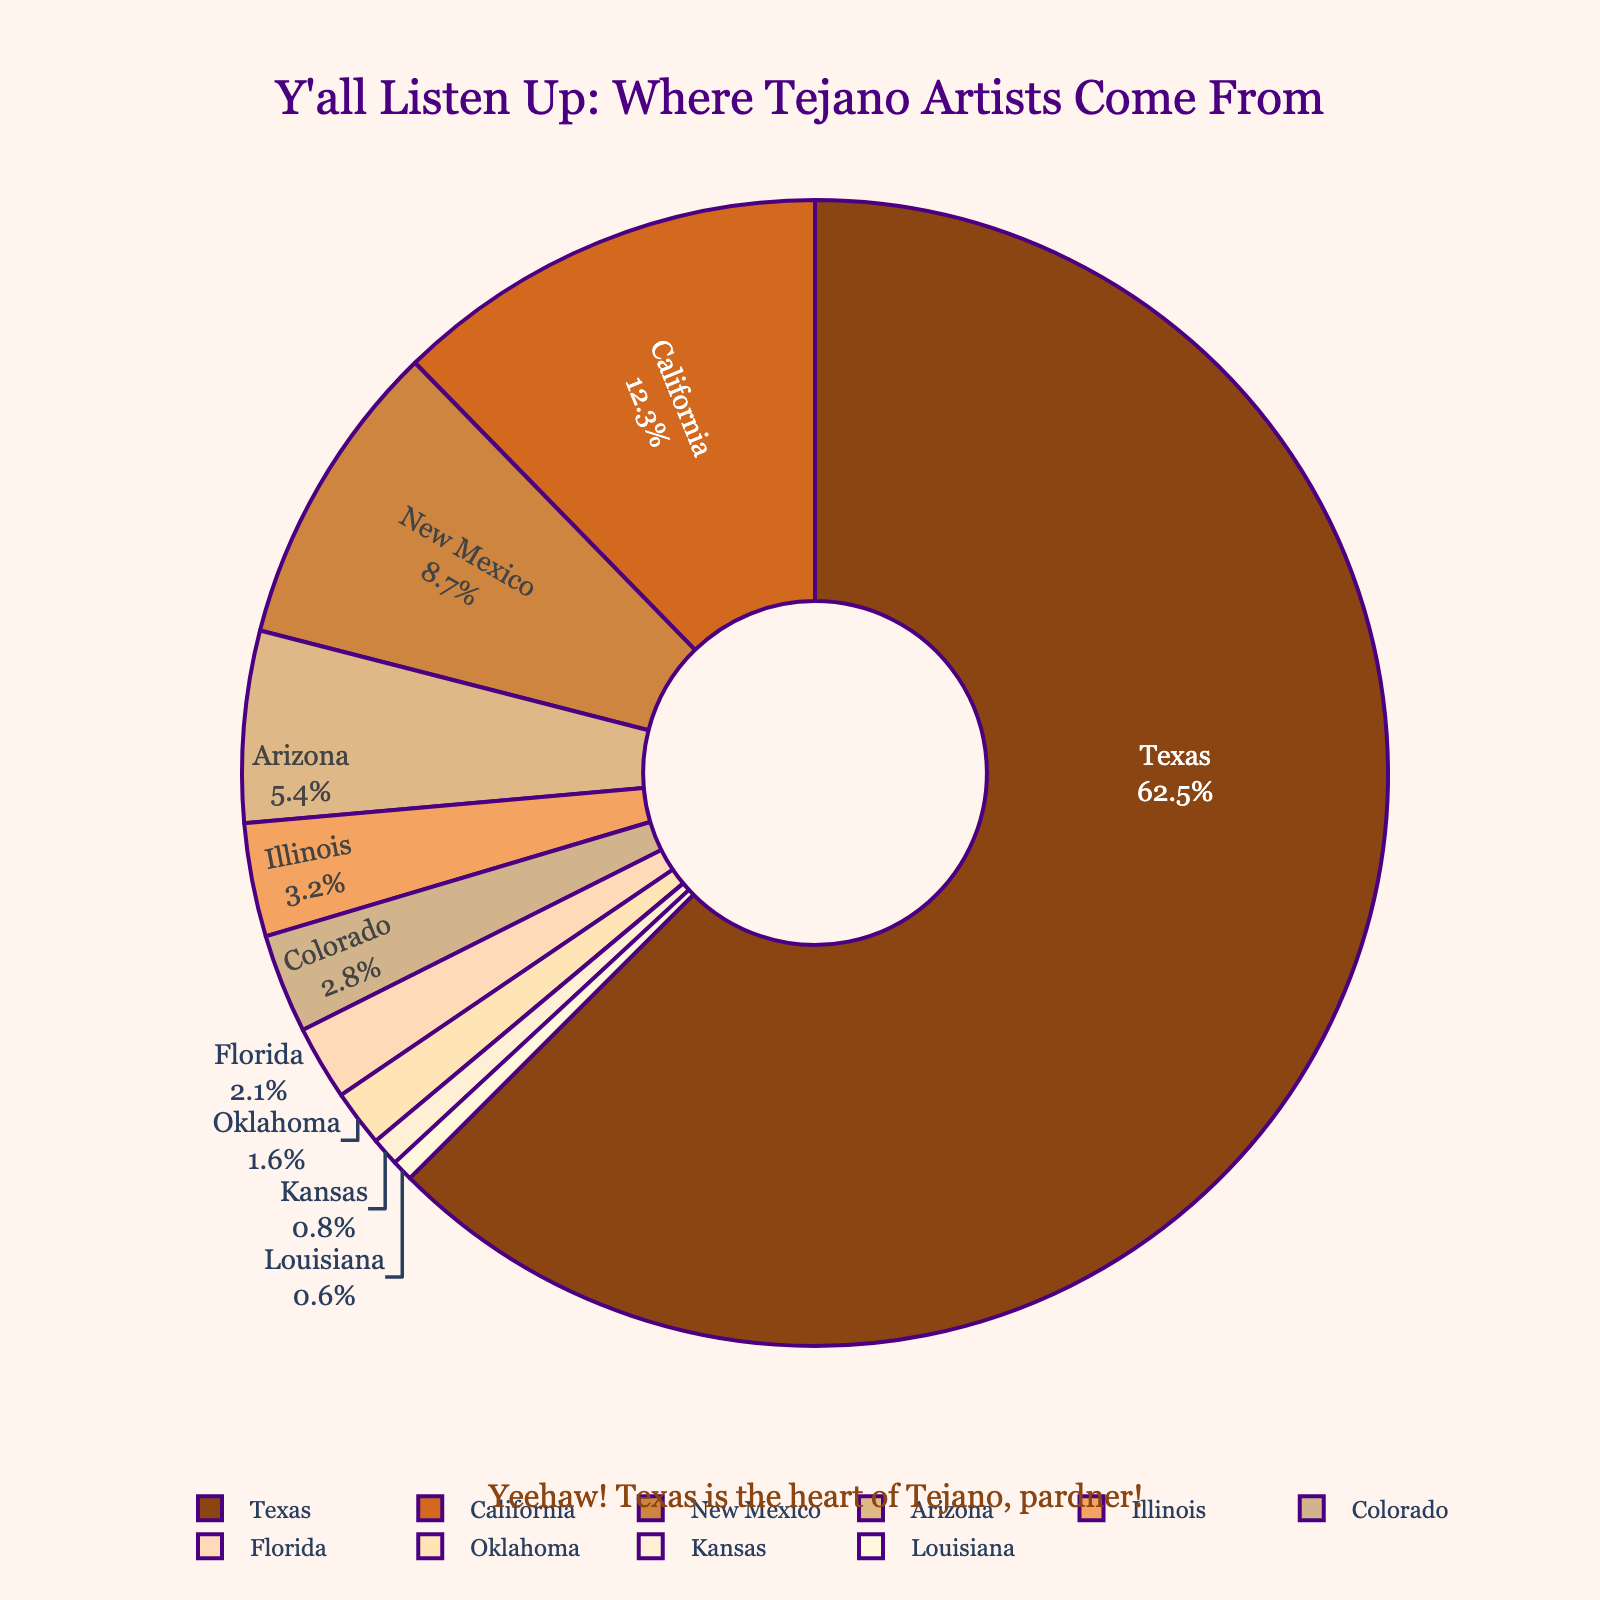What's the largest proportion of Tejano music artists from a single state? The pie chart shows that Texas has the largest segment. By inspecting the percentages, Texas has 62.5%, which is the biggest proportion among all states.
Answer: 62.5% Which state has the second highest proportion of Tejano music artists after Texas? By looking at the pie chart, after Texas, California has the next largest portion. The chart shows California at 12.3%.
Answer: California How much more is the proportion of Tejano artists from Texas compared to New Mexico? The proportions are 62.5% (Texas) and 8.7% (New Mexico). The difference is calculated as 62.5% - 8.7% = 53.8%.
Answer: 53.8% What is the combined proportion of Tejano artists from Arizona and Illinois? The pie chart indicates Arizona has 5.4% and Illinois has 3.2%. By adding these, 5.4% + 3.2% = 8.6%.
Answer: 8.6% Are there more Tejano artists from Colorado or Florida? The chart shows Colorado at 2.8% and Florida at 2.1%. Since 2.8% is greater than 2.1%, there are more artists from Colorado.
Answer: Colorado Which colors are used to represent California and New Mexico on the pie chart? The slice for California is a shade of orange, and New Mexico is also a shade of tan/brown. The exact shades aren't specified but can be inferred from their visual representation.
Answer: Orange (California), Tan/Brown (New Mexico) What is the sum of the proportions of Tejano artists from the bottom four states? The bottom four states are Florida (2.1%), Oklahoma (1.6%), Kansas (0.8%), and Louisiana (0.6%). Adding these gives 2.1% + 1.6% + 0.8% + 0.6% = 5.1%.
Answer: 5.1% How does the proportion of Oklahoma compare to Kansas? Oklahoma has a proportion of 1.6%, while Kansas has 0.8%. Since 1.6% is greater than 0.8%, Oklahoma has a higher proportion.
Answer: Oklahoma Which state is represented by the smallest proportion in the pie chart? By inspecting the pie chart and its percentages, Louisiana has the smallest proportion at 0.6%.
Answer: Louisiana What is the difference between the proportions of Tejano artists from California and Arizona? California has 12.3% and Arizona has 5.4%. The difference is 12.3% - 5.4% = 6.9%.
Answer: 6.9% 